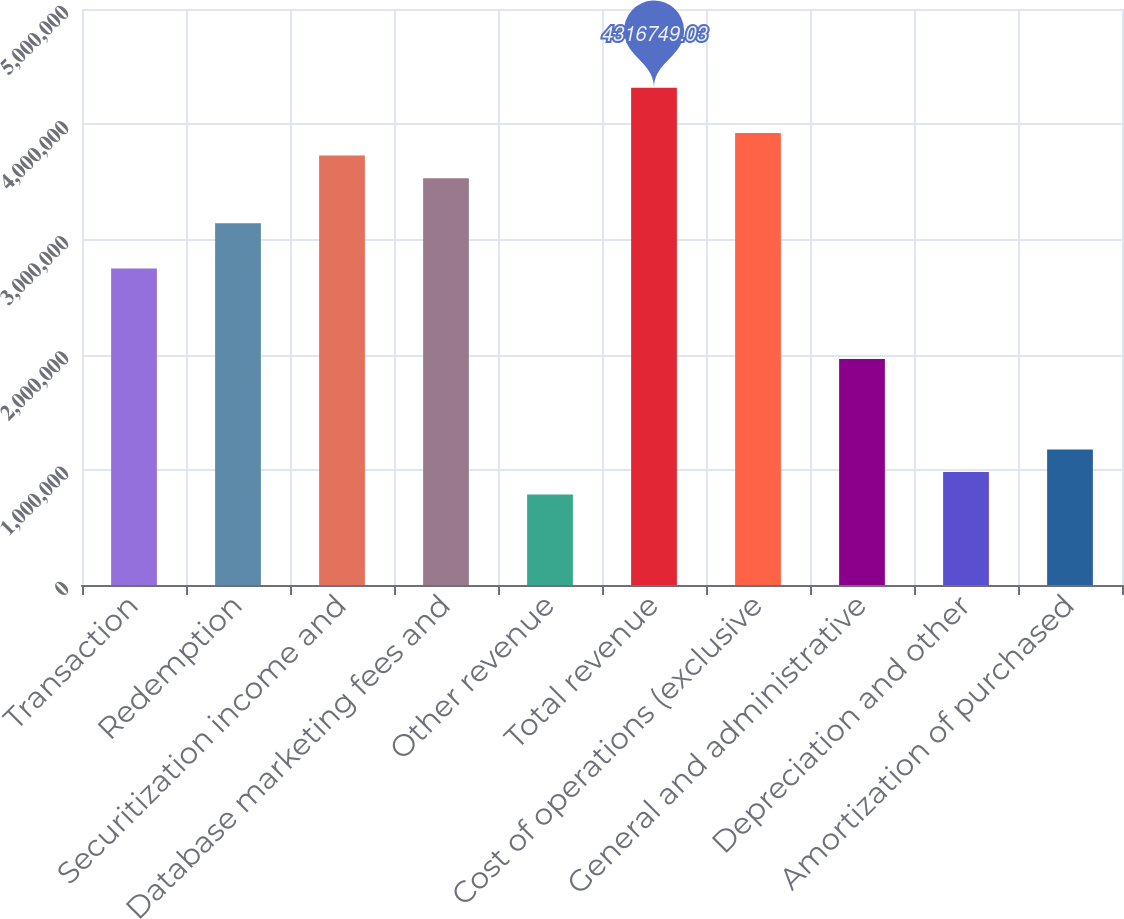Convert chart to OTSL. <chart><loc_0><loc_0><loc_500><loc_500><bar_chart><fcel>Transaction<fcel>Redemption<fcel>Securitization income and<fcel>Database marketing fees and<fcel>Other revenue<fcel>Total revenue<fcel>Cost of operations (exclusive<fcel>General and administrative<fcel>Depreciation and other<fcel>Amortization of purchased<nl><fcel>2.74702e+06<fcel>3.13945e+06<fcel>3.7281e+06<fcel>3.53189e+06<fcel>784864<fcel>4.31675e+06<fcel>3.92432e+06<fcel>1.96216e+06<fcel>981080<fcel>1.1773e+06<nl></chart> 